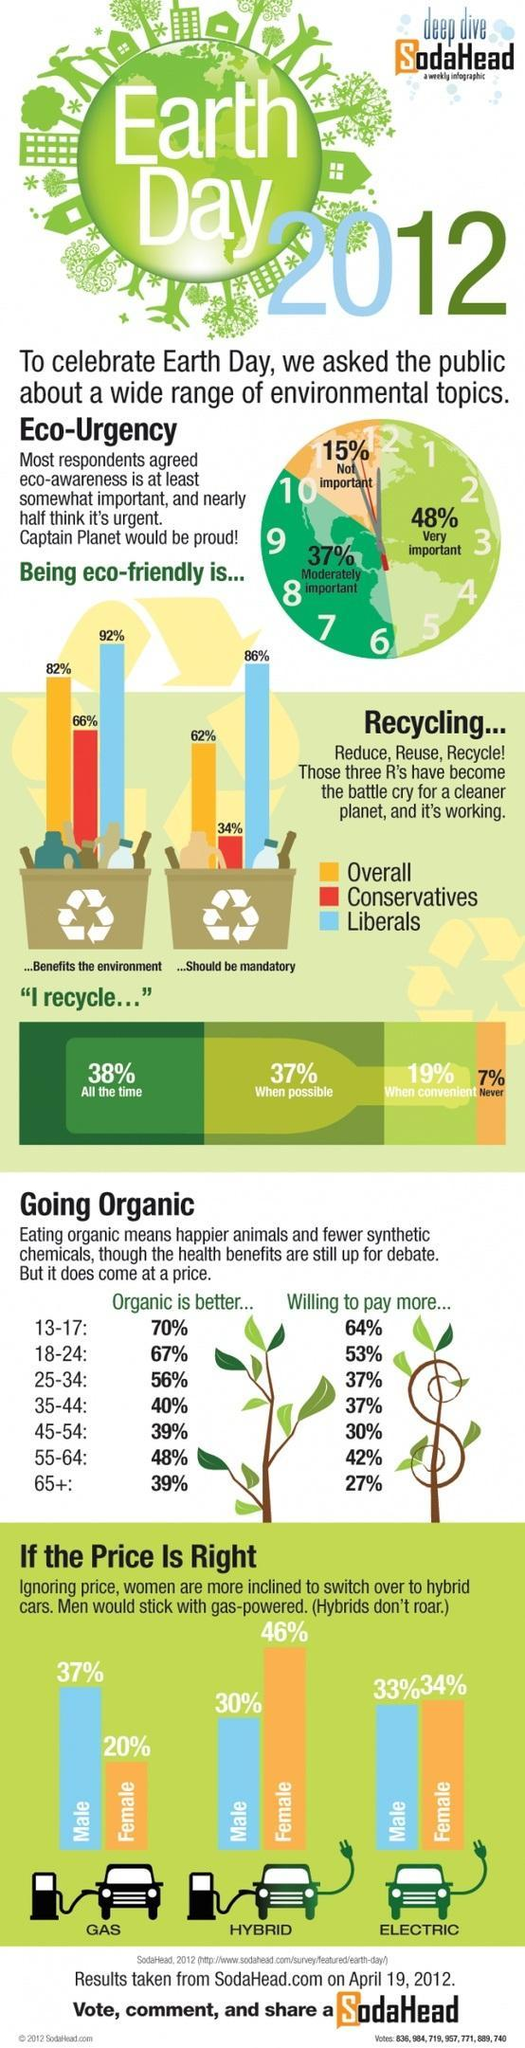What is the overall percentage of respondents who feel that recycling should be mandatory?
Answer the question with a short phrase. 62% What is the percentage in women switching to electric cars ? 1% What percentage of conservatives feel recycling should be mandatory? 34% What is written inside the image of a globe? Earth Day What is the percentage of people who recycle as and when it is plausible? 37% If 39% of respondents feel that organic food is better, then which age groups do they belong to? 45-54, 65+ What percentage of people aged between 25-44 are willing to pay more for organic food? 37% What percentage of respondents feel that environment awareness need to be developed immediately? 48% What percentage of liberals understand the benefits of the environment? 92% Which age group is willing to pay more for organic food? 13-17 